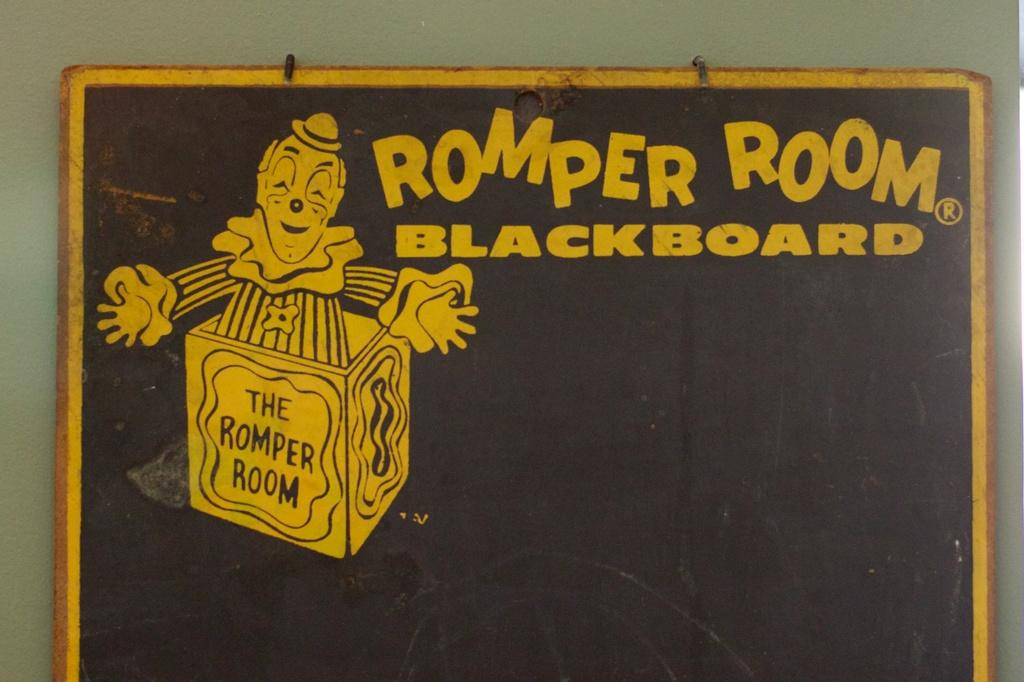What is the main object in the image? There is a blackboard in the image. Where is the blackboard located? The blackboard is placed in front of a wall. What is depicted on the blackboard? There is an image of a joker on the blackboard. Are there any names written on the blackboard? Yes, some names are written beside the image of the joker. What color are the names written in? The names are written in yellow color. What type of pin can be seen holding the border of the blackboard in the image? There is no pin or border present in the image; it only features a blackboard with an image of a joker and some names written in yellow color. 